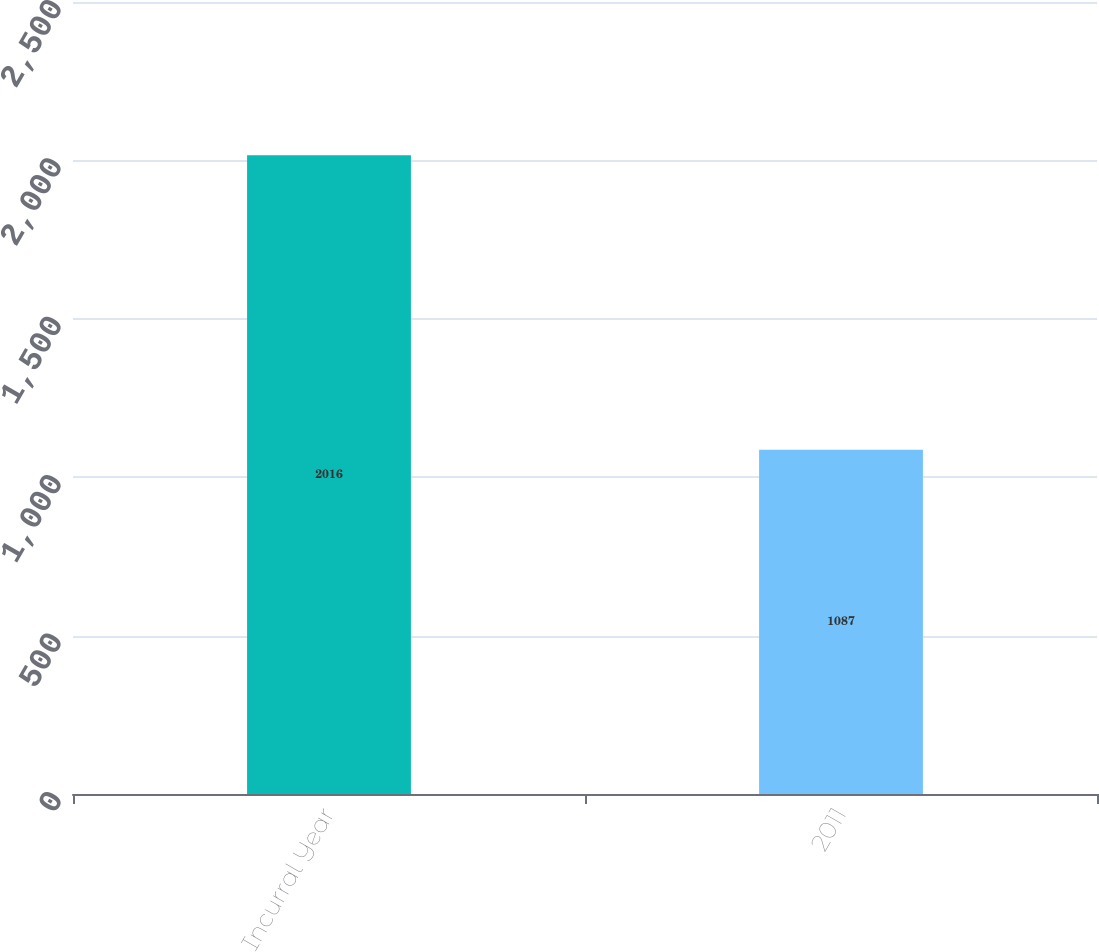Convert chart to OTSL. <chart><loc_0><loc_0><loc_500><loc_500><bar_chart><fcel>Incurral Year<fcel>2011<nl><fcel>2016<fcel>1087<nl></chart> 